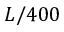Convert formula to latex. <formula><loc_0><loc_0><loc_500><loc_500>L / 4 0 0</formula> 